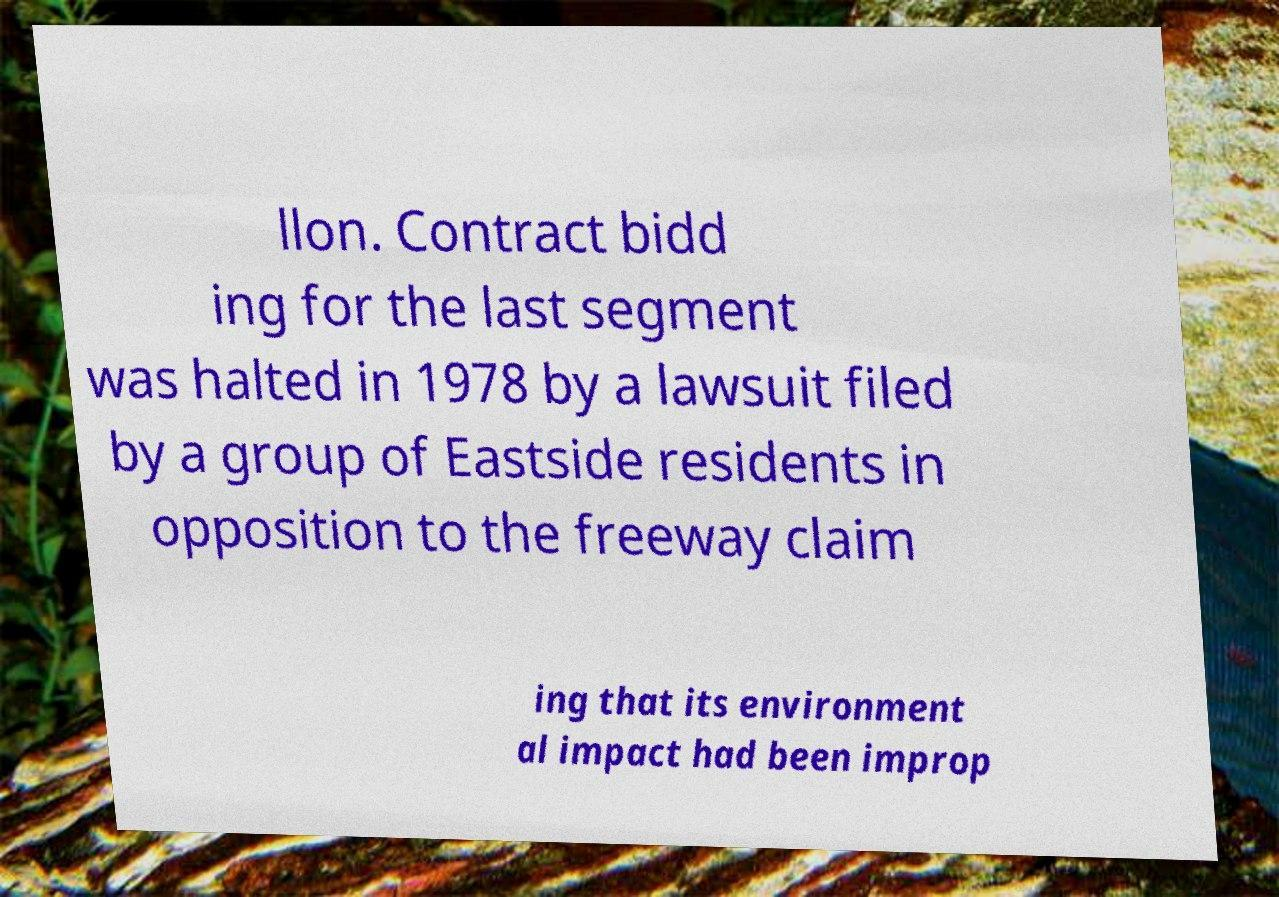Can you read and provide the text displayed in the image?This photo seems to have some interesting text. Can you extract and type it out for me? llon. Contract bidd ing for the last segment was halted in 1978 by a lawsuit filed by a group of Eastside residents in opposition to the freeway claim ing that its environment al impact had been improp 